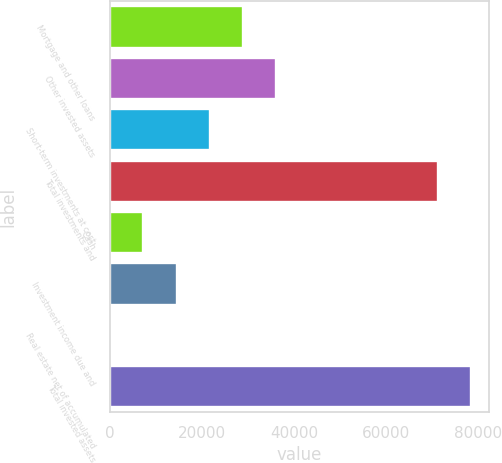Convert chart. <chart><loc_0><loc_0><loc_500><loc_500><bar_chart><fcel>Mortgage and other loans<fcel>Other invested assets<fcel>Short-term investments at cost<fcel>Total investments and<fcel>Cash<fcel>Investment income due and<fcel>Real estate net of accumulated<fcel>Total invested assets<nl><fcel>28870.6<fcel>36066<fcel>21675.2<fcel>71284<fcel>7284.4<fcel>14479.8<fcel>89<fcel>78479.4<nl></chart> 